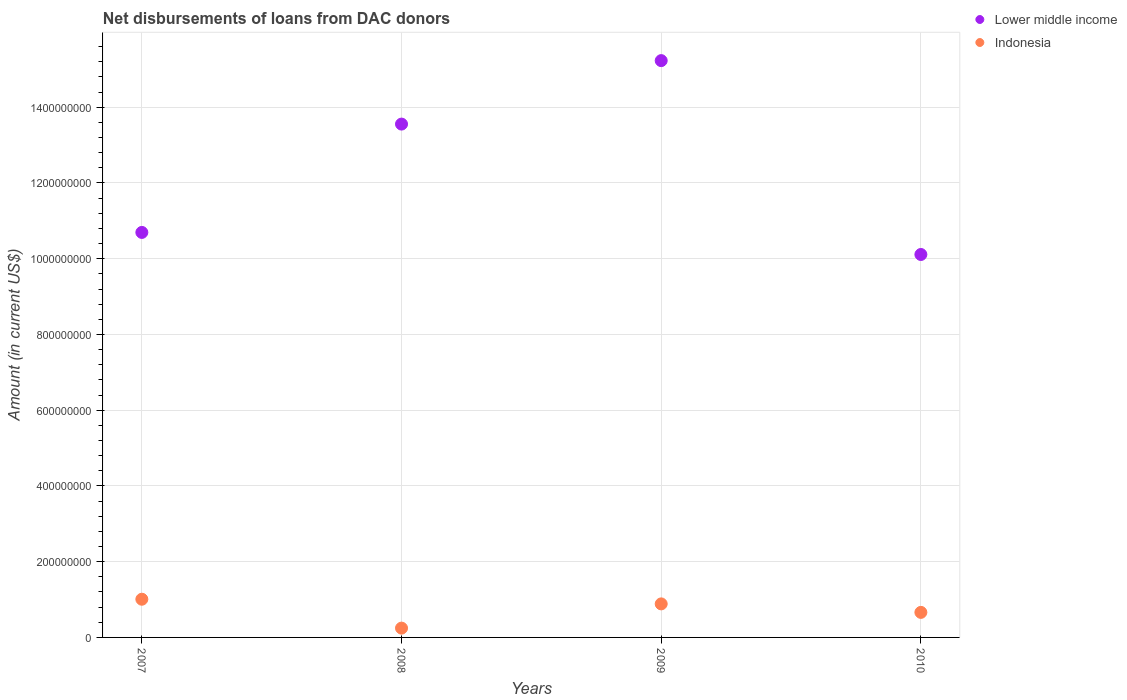What is the amount of loans disbursed in Lower middle income in 2008?
Ensure brevity in your answer.  1.36e+09. Across all years, what is the maximum amount of loans disbursed in Indonesia?
Ensure brevity in your answer.  1.01e+08. Across all years, what is the minimum amount of loans disbursed in Lower middle income?
Your answer should be compact. 1.01e+09. In which year was the amount of loans disbursed in Indonesia maximum?
Your response must be concise. 2007. What is the total amount of loans disbursed in Lower middle income in the graph?
Your answer should be very brief. 4.96e+09. What is the difference between the amount of loans disbursed in Indonesia in 2008 and that in 2010?
Offer a terse response. -4.16e+07. What is the difference between the amount of loans disbursed in Lower middle income in 2009 and the amount of loans disbursed in Indonesia in 2007?
Ensure brevity in your answer.  1.42e+09. What is the average amount of loans disbursed in Indonesia per year?
Offer a terse response. 7.00e+07. In the year 2009, what is the difference between the amount of loans disbursed in Lower middle income and amount of loans disbursed in Indonesia?
Offer a terse response. 1.43e+09. In how many years, is the amount of loans disbursed in Lower middle income greater than 200000000 US$?
Provide a succinct answer. 4. What is the ratio of the amount of loans disbursed in Indonesia in 2008 to that in 2009?
Offer a very short reply. 0.28. Is the amount of loans disbursed in Lower middle income in 2007 less than that in 2010?
Offer a terse response. No. Is the difference between the amount of loans disbursed in Lower middle income in 2007 and 2008 greater than the difference between the amount of loans disbursed in Indonesia in 2007 and 2008?
Your response must be concise. No. What is the difference between the highest and the second highest amount of loans disbursed in Lower middle income?
Keep it short and to the point. 1.68e+08. What is the difference between the highest and the lowest amount of loans disbursed in Lower middle income?
Make the answer very short. 5.12e+08. Does the amount of loans disbursed in Lower middle income monotonically increase over the years?
Offer a very short reply. No. Is the amount of loans disbursed in Lower middle income strictly greater than the amount of loans disbursed in Indonesia over the years?
Offer a terse response. Yes. Is the amount of loans disbursed in Indonesia strictly less than the amount of loans disbursed in Lower middle income over the years?
Give a very brief answer. Yes. How many dotlines are there?
Your answer should be very brief. 2. How many years are there in the graph?
Ensure brevity in your answer.  4. What is the difference between two consecutive major ticks on the Y-axis?
Give a very brief answer. 2.00e+08. Are the values on the major ticks of Y-axis written in scientific E-notation?
Give a very brief answer. No. Does the graph contain any zero values?
Provide a succinct answer. No. Where does the legend appear in the graph?
Your answer should be very brief. Top right. How are the legend labels stacked?
Give a very brief answer. Vertical. What is the title of the graph?
Your answer should be compact. Net disbursements of loans from DAC donors. Does "Central Europe" appear as one of the legend labels in the graph?
Your response must be concise. No. What is the label or title of the Y-axis?
Make the answer very short. Amount (in current US$). What is the Amount (in current US$) of Lower middle income in 2007?
Keep it short and to the point. 1.07e+09. What is the Amount (in current US$) in Indonesia in 2007?
Your answer should be very brief. 1.01e+08. What is the Amount (in current US$) of Lower middle income in 2008?
Your answer should be very brief. 1.36e+09. What is the Amount (in current US$) in Indonesia in 2008?
Ensure brevity in your answer.  2.46e+07. What is the Amount (in current US$) in Lower middle income in 2009?
Offer a terse response. 1.52e+09. What is the Amount (in current US$) in Indonesia in 2009?
Give a very brief answer. 8.86e+07. What is the Amount (in current US$) of Lower middle income in 2010?
Give a very brief answer. 1.01e+09. What is the Amount (in current US$) in Indonesia in 2010?
Make the answer very short. 6.61e+07. Across all years, what is the maximum Amount (in current US$) in Lower middle income?
Your answer should be very brief. 1.52e+09. Across all years, what is the maximum Amount (in current US$) of Indonesia?
Offer a very short reply. 1.01e+08. Across all years, what is the minimum Amount (in current US$) of Lower middle income?
Your response must be concise. 1.01e+09. Across all years, what is the minimum Amount (in current US$) in Indonesia?
Your response must be concise. 2.46e+07. What is the total Amount (in current US$) in Lower middle income in the graph?
Give a very brief answer. 4.96e+09. What is the total Amount (in current US$) of Indonesia in the graph?
Your answer should be compact. 2.80e+08. What is the difference between the Amount (in current US$) of Lower middle income in 2007 and that in 2008?
Your answer should be very brief. -2.86e+08. What is the difference between the Amount (in current US$) of Indonesia in 2007 and that in 2008?
Give a very brief answer. 7.63e+07. What is the difference between the Amount (in current US$) in Lower middle income in 2007 and that in 2009?
Offer a very short reply. -4.54e+08. What is the difference between the Amount (in current US$) in Indonesia in 2007 and that in 2009?
Provide a succinct answer. 1.23e+07. What is the difference between the Amount (in current US$) in Lower middle income in 2007 and that in 2010?
Your answer should be compact. 5.83e+07. What is the difference between the Amount (in current US$) in Indonesia in 2007 and that in 2010?
Give a very brief answer. 3.47e+07. What is the difference between the Amount (in current US$) of Lower middle income in 2008 and that in 2009?
Provide a succinct answer. -1.68e+08. What is the difference between the Amount (in current US$) in Indonesia in 2008 and that in 2009?
Your response must be concise. -6.40e+07. What is the difference between the Amount (in current US$) of Lower middle income in 2008 and that in 2010?
Keep it short and to the point. 3.44e+08. What is the difference between the Amount (in current US$) in Indonesia in 2008 and that in 2010?
Your response must be concise. -4.16e+07. What is the difference between the Amount (in current US$) in Lower middle income in 2009 and that in 2010?
Provide a succinct answer. 5.12e+08. What is the difference between the Amount (in current US$) in Indonesia in 2009 and that in 2010?
Make the answer very short. 2.24e+07. What is the difference between the Amount (in current US$) of Lower middle income in 2007 and the Amount (in current US$) of Indonesia in 2008?
Provide a short and direct response. 1.04e+09. What is the difference between the Amount (in current US$) of Lower middle income in 2007 and the Amount (in current US$) of Indonesia in 2009?
Keep it short and to the point. 9.81e+08. What is the difference between the Amount (in current US$) of Lower middle income in 2007 and the Amount (in current US$) of Indonesia in 2010?
Your answer should be very brief. 1.00e+09. What is the difference between the Amount (in current US$) in Lower middle income in 2008 and the Amount (in current US$) in Indonesia in 2009?
Offer a terse response. 1.27e+09. What is the difference between the Amount (in current US$) in Lower middle income in 2008 and the Amount (in current US$) in Indonesia in 2010?
Ensure brevity in your answer.  1.29e+09. What is the difference between the Amount (in current US$) in Lower middle income in 2009 and the Amount (in current US$) in Indonesia in 2010?
Offer a very short reply. 1.46e+09. What is the average Amount (in current US$) in Lower middle income per year?
Your answer should be compact. 1.24e+09. What is the average Amount (in current US$) of Indonesia per year?
Your answer should be compact. 7.00e+07. In the year 2007, what is the difference between the Amount (in current US$) of Lower middle income and Amount (in current US$) of Indonesia?
Offer a terse response. 9.69e+08. In the year 2008, what is the difference between the Amount (in current US$) of Lower middle income and Amount (in current US$) of Indonesia?
Provide a succinct answer. 1.33e+09. In the year 2009, what is the difference between the Amount (in current US$) in Lower middle income and Amount (in current US$) in Indonesia?
Offer a terse response. 1.43e+09. In the year 2010, what is the difference between the Amount (in current US$) of Lower middle income and Amount (in current US$) of Indonesia?
Make the answer very short. 9.45e+08. What is the ratio of the Amount (in current US$) of Lower middle income in 2007 to that in 2008?
Give a very brief answer. 0.79. What is the ratio of the Amount (in current US$) in Indonesia in 2007 to that in 2008?
Your answer should be very brief. 4.11. What is the ratio of the Amount (in current US$) in Lower middle income in 2007 to that in 2009?
Make the answer very short. 0.7. What is the ratio of the Amount (in current US$) in Indonesia in 2007 to that in 2009?
Keep it short and to the point. 1.14. What is the ratio of the Amount (in current US$) in Lower middle income in 2007 to that in 2010?
Your answer should be compact. 1.06. What is the ratio of the Amount (in current US$) in Indonesia in 2007 to that in 2010?
Offer a very short reply. 1.52. What is the ratio of the Amount (in current US$) of Lower middle income in 2008 to that in 2009?
Offer a very short reply. 0.89. What is the ratio of the Amount (in current US$) of Indonesia in 2008 to that in 2009?
Keep it short and to the point. 0.28. What is the ratio of the Amount (in current US$) of Lower middle income in 2008 to that in 2010?
Offer a terse response. 1.34. What is the ratio of the Amount (in current US$) of Indonesia in 2008 to that in 2010?
Your response must be concise. 0.37. What is the ratio of the Amount (in current US$) in Lower middle income in 2009 to that in 2010?
Ensure brevity in your answer.  1.51. What is the ratio of the Amount (in current US$) of Indonesia in 2009 to that in 2010?
Ensure brevity in your answer.  1.34. What is the difference between the highest and the second highest Amount (in current US$) of Lower middle income?
Your answer should be compact. 1.68e+08. What is the difference between the highest and the second highest Amount (in current US$) in Indonesia?
Keep it short and to the point. 1.23e+07. What is the difference between the highest and the lowest Amount (in current US$) of Lower middle income?
Ensure brevity in your answer.  5.12e+08. What is the difference between the highest and the lowest Amount (in current US$) in Indonesia?
Make the answer very short. 7.63e+07. 